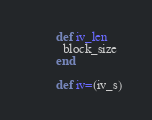<code> <loc_0><loc_0><loc_500><loc_500><_Ruby_>        def iv_len
          block_size
        end

        def iv=(iv_s)</code> 